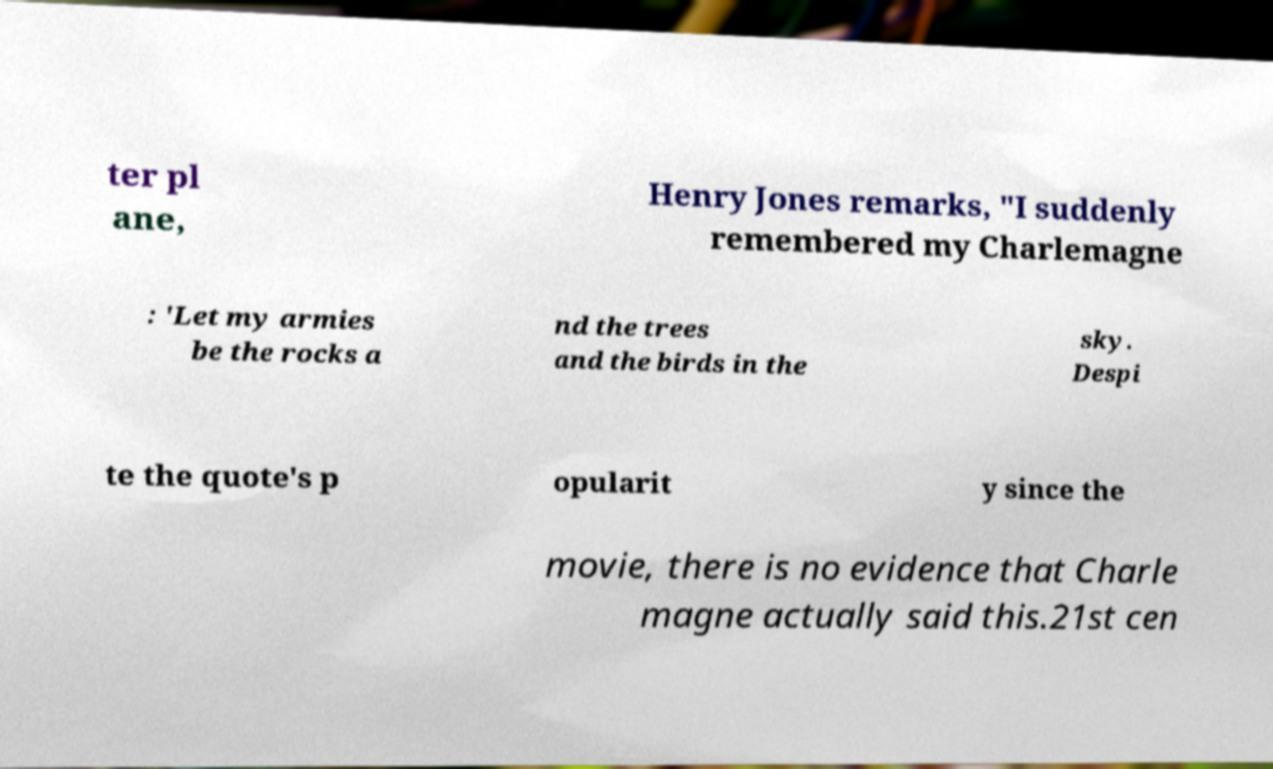Could you extract and type out the text from this image? ter pl ane, Henry Jones remarks, "I suddenly remembered my Charlemagne : 'Let my armies be the rocks a nd the trees and the birds in the sky. Despi te the quote's p opularit y since the movie, there is no evidence that Charle magne actually said this.21st cen 